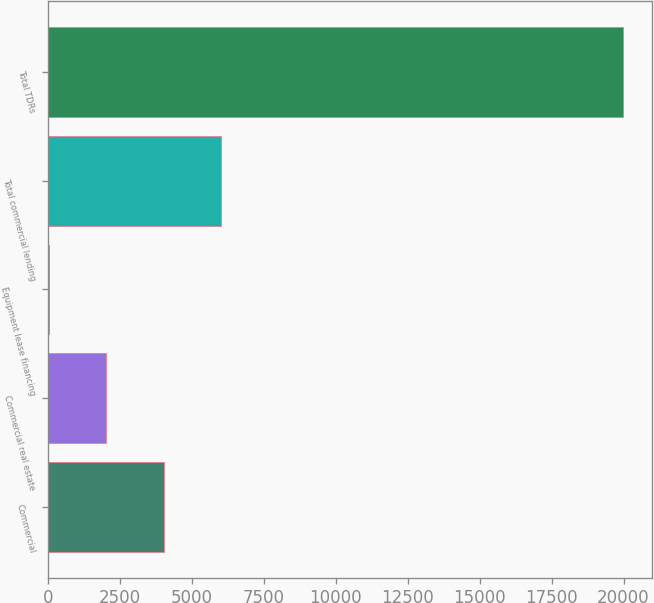Convert chart. <chart><loc_0><loc_0><loc_500><loc_500><bar_chart><fcel>Commercial<fcel>Commercial real estate<fcel>Equipment lease financing<fcel>Total commercial lending<fcel>Total TDRs<nl><fcel>4007.4<fcel>2008.7<fcel>10<fcel>6006.1<fcel>19997<nl></chart> 